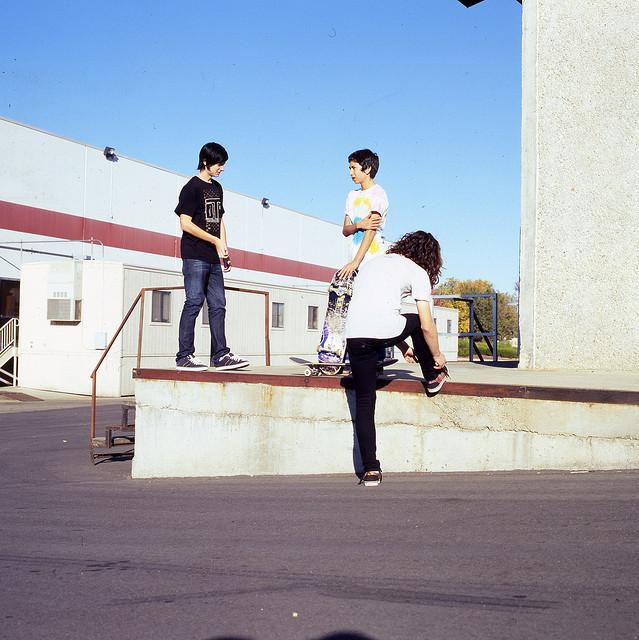Why is the long haired boy touching his shoe? Please explain your reasoning. tying laces. The long haired boy is touching his shoe, attempting to tie his laces. 